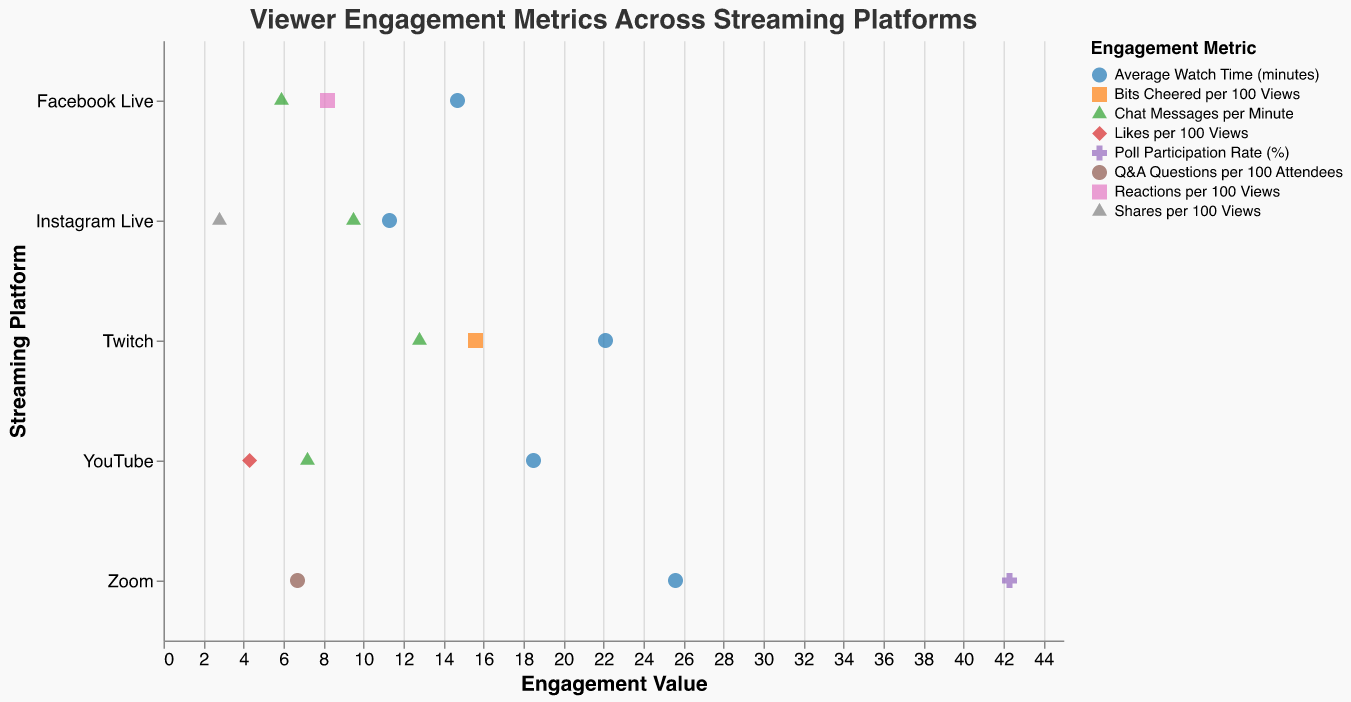Which platform has the highest average watch time? Look for the "Average Watch Time (minutes)" metric and compare the values across all platforms. Zoom has the highest value of 25.6 minutes.
Answer: Zoom What is the engagement metric with the lowest value on YouTube? Identify all engagement metrics for YouTube by their values. The metric with the lowest value is "Likes per 100 Views" at 4.3.
Answer: Likes per 100 Views How do the chat messages per minute compare between Twitch and Instagram Live? Extract the "Chat Messages per Minute" metric from both platforms. Twitch has 12.8 chat messages per minute, while Instagram Live has 9.5. Since 12.8 > 9.5, Twitch is higher.
Answer: Twitch has more chat messages per minute Which platform shows the most engagement in terms of poll participation? Poll participation is only measured on Zoom with a 42.3% rate. Identify that it’s only present on the Zoom platform.
Answer: Zoom What's the combined value of chat messages per minute for Facebook Live and YouTube? Extract the values for "Chat Messages per Minute" from both platforms, which are 5.9 for Facebook Live and 7.2 for YouTube. Combine them: 5.9 + 7.2 = 13.1.
Answer: 13.1 Which platform has the highest variance in engagement metrics? Calculate variance using all the metrics available for each platform. Manually check each platform: 
YouTube: (18.5, 7.2, 4.3)
Twitch: (22.1, 12.8, 15.6)
Facebook Live: (14.7, 5.9, 8.2)
Instagram Live: (11.3, 9.5, 2.8)
Zoom: (25.6, 6.7, 42.3)
Due to the widely spread values (25.6, 6.7, 42.3), Zoom has the highest variance.
Answer: Zoom How does the value of Q&A questions on Zoom compare with the average watch time on Instagram Live? The value for "Q&A Questions per 100 Attendees" on Zoom is 6.7 and for "Average Watch Time (minutes)" on Instagram Live is 11.3. Comparing them shows 6.7 < 11.3.
Answer: Instagram Live has a higher value Which platform has the lowest value in terms of average watch time and what is it? Identify the "Average Watch Time (minutes)" metric across all platforms and find the lowest value, which is Instagram Live with 11.3 minutes.
Answer: Instagram Live, 11.3 What is the total number of engagement metrics displayed for YouTube and Zoom combined? Count the number of engagement metrics for YouTube (3) and for Zoom (3). Add them together: 3 + 3 = 6.
Answer: 6 